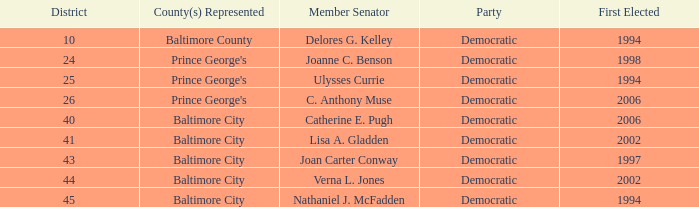What district for ulysses currie? 25.0. 